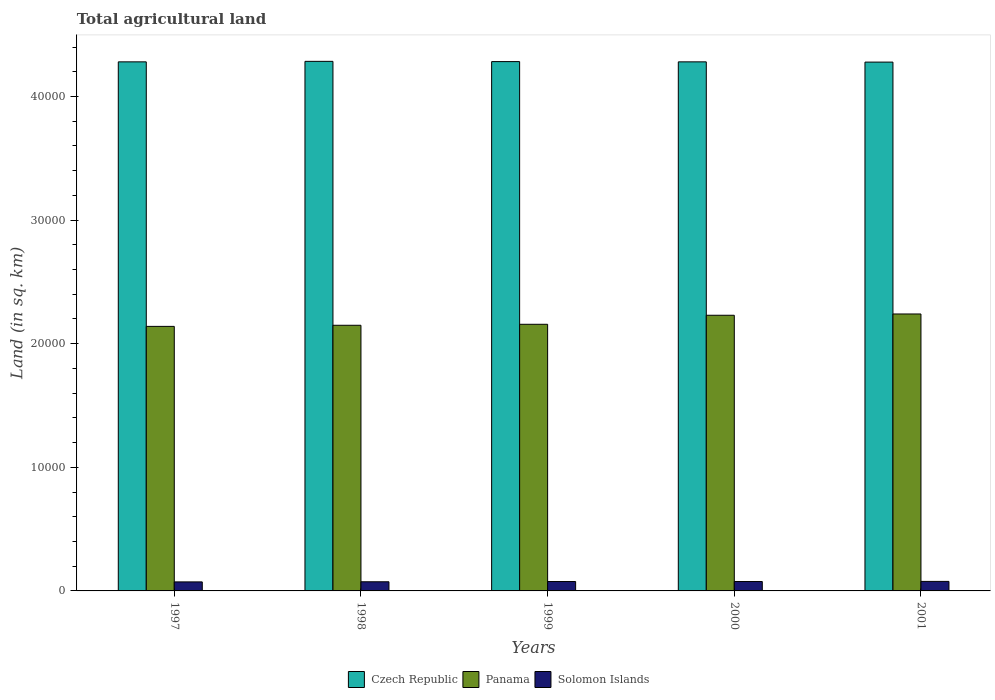How many groups of bars are there?
Offer a terse response. 5. Are the number of bars on each tick of the X-axis equal?
Make the answer very short. Yes. How many bars are there on the 1st tick from the right?
Your response must be concise. 3. What is the total agricultural land in Solomon Islands in 2001?
Offer a terse response. 770. Across all years, what is the maximum total agricultural land in Solomon Islands?
Provide a short and direct response. 770. Across all years, what is the minimum total agricultural land in Czech Republic?
Provide a short and direct response. 4.28e+04. In which year was the total agricultural land in Panama maximum?
Provide a short and direct response. 2001. What is the total total agricultural land in Panama in the graph?
Offer a terse response. 1.09e+05. What is the difference between the total agricultural land in Panama in 1997 and that in 1999?
Provide a succinct answer. -170. What is the difference between the total agricultural land in Solomon Islands in 2001 and the total agricultural land in Czech Republic in 1999?
Give a very brief answer. -4.20e+04. What is the average total agricultural land in Solomon Islands per year?
Make the answer very short. 752. In the year 1997, what is the difference between the total agricultural land in Panama and total agricultural land in Solomon Islands?
Ensure brevity in your answer.  2.07e+04. What is the ratio of the total agricultural land in Panama in 1998 to that in 2000?
Keep it short and to the point. 0.96. Is the total agricultural land in Czech Republic in 1998 less than that in 2000?
Ensure brevity in your answer.  No. Is the difference between the total agricultural land in Panama in 1997 and 1999 greater than the difference between the total agricultural land in Solomon Islands in 1997 and 1999?
Your answer should be compact. No. What is the difference between the highest and the second highest total agricultural land in Solomon Islands?
Your response must be concise. 10. What is the difference between the highest and the lowest total agricultural land in Solomon Islands?
Provide a succinct answer. 40. In how many years, is the total agricultural land in Panama greater than the average total agricultural land in Panama taken over all years?
Provide a short and direct response. 2. What does the 2nd bar from the left in 2001 represents?
Give a very brief answer. Panama. What does the 3rd bar from the right in 1998 represents?
Offer a very short reply. Czech Republic. Is it the case that in every year, the sum of the total agricultural land in Czech Republic and total agricultural land in Panama is greater than the total agricultural land in Solomon Islands?
Offer a terse response. Yes. How many bars are there?
Make the answer very short. 15. Are all the bars in the graph horizontal?
Your answer should be very brief. No. What is the difference between two consecutive major ticks on the Y-axis?
Offer a terse response. 10000. Does the graph contain any zero values?
Make the answer very short. No. How many legend labels are there?
Your response must be concise. 3. What is the title of the graph?
Your answer should be compact. Total agricultural land. What is the label or title of the Y-axis?
Offer a very short reply. Land (in sq. km). What is the Land (in sq. km) in Czech Republic in 1997?
Keep it short and to the point. 4.28e+04. What is the Land (in sq. km) in Panama in 1997?
Provide a short and direct response. 2.14e+04. What is the Land (in sq. km) in Solomon Islands in 1997?
Offer a very short reply. 730. What is the Land (in sq. km) of Czech Republic in 1998?
Your response must be concise. 4.28e+04. What is the Land (in sq. km) in Panama in 1998?
Your answer should be compact. 2.15e+04. What is the Land (in sq. km) of Solomon Islands in 1998?
Ensure brevity in your answer.  740. What is the Land (in sq. km) in Czech Republic in 1999?
Your answer should be compact. 4.28e+04. What is the Land (in sq. km) in Panama in 1999?
Your answer should be very brief. 2.16e+04. What is the Land (in sq. km) in Solomon Islands in 1999?
Provide a succinct answer. 760. What is the Land (in sq. km) in Czech Republic in 2000?
Your answer should be very brief. 4.28e+04. What is the Land (in sq. km) in Panama in 2000?
Offer a terse response. 2.23e+04. What is the Land (in sq. km) of Solomon Islands in 2000?
Make the answer very short. 760. What is the Land (in sq. km) in Czech Republic in 2001?
Ensure brevity in your answer.  4.28e+04. What is the Land (in sq. km) in Panama in 2001?
Keep it short and to the point. 2.24e+04. What is the Land (in sq. km) in Solomon Islands in 2001?
Offer a terse response. 770. Across all years, what is the maximum Land (in sq. km) in Czech Republic?
Provide a short and direct response. 4.28e+04. Across all years, what is the maximum Land (in sq. km) of Panama?
Make the answer very short. 2.24e+04. Across all years, what is the maximum Land (in sq. km) in Solomon Islands?
Your response must be concise. 770. Across all years, what is the minimum Land (in sq. km) of Czech Republic?
Your answer should be compact. 4.28e+04. Across all years, what is the minimum Land (in sq. km) of Panama?
Ensure brevity in your answer.  2.14e+04. Across all years, what is the minimum Land (in sq. km) in Solomon Islands?
Give a very brief answer. 730. What is the total Land (in sq. km) in Czech Republic in the graph?
Give a very brief answer. 2.14e+05. What is the total Land (in sq. km) of Panama in the graph?
Give a very brief answer. 1.09e+05. What is the total Land (in sq. km) in Solomon Islands in the graph?
Keep it short and to the point. 3760. What is the difference between the Land (in sq. km) of Panama in 1997 and that in 1998?
Keep it short and to the point. -90. What is the difference between the Land (in sq. km) of Czech Republic in 1997 and that in 1999?
Provide a short and direct response. -20. What is the difference between the Land (in sq. km) of Panama in 1997 and that in 1999?
Keep it short and to the point. -170. What is the difference between the Land (in sq. km) in Solomon Islands in 1997 and that in 1999?
Offer a terse response. -30. What is the difference between the Land (in sq. km) in Panama in 1997 and that in 2000?
Your response must be concise. -900. What is the difference between the Land (in sq. km) in Solomon Islands in 1997 and that in 2000?
Keep it short and to the point. -30. What is the difference between the Land (in sq. km) in Panama in 1997 and that in 2001?
Offer a very short reply. -1004. What is the difference between the Land (in sq. km) of Czech Republic in 1998 and that in 1999?
Make the answer very short. 20. What is the difference between the Land (in sq. km) in Panama in 1998 and that in 1999?
Offer a terse response. -80. What is the difference between the Land (in sq. km) of Solomon Islands in 1998 and that in 1999?
Make the answer very short. -20. What is the difference between the Land (in sq. km) in Panama in 1998 and that in 2000?
Your answer should be very brief. -810. What is the difference between the Land (in sq. km) in Panama in 1998 and that in 2001?
Give a very brief answer. -914. What is the difference between the Land (in sq. km) of Czech Republic in 1999 and that in 2000?
Your response must be concise. 20. What is the difference between the Land (in sq. km) in Panama in 1999 and that in 2000?
Your answer should be compact. -730. What is the difference between the Land (in sq. km) in Solomon Islands in 1999 and that in 2000?
Your answer should be compact. 0. What is the difference between the Land (in sq. km) in Czech Republic in 1999 and that in 2001?
Ensure brevity in your answer.  40. What is the difference between the Land (in sq. km) of Panama in 1999 and that in 2001?
Provide a succinct answer. -834. What is the difference between the Land (in sq. km) of Solomon Islands in 1999 and that in 2001?
Ensure brevity in your answer.  -10. What is the difference between the Land (in sq. km) in Czech Republic in 2000 and that in 2001?
Keep it short and to the point. 20. What is the difference between the Land (in sq. km) of Panama in 2000 and that in 2001?
Your response must be concise. -104. What is the difference between the Land (in sq. km) of Solomon Islands in 2000 and that in 2001?
Offer a very short reply. -10. What is the difference between the Land (in sq. km) of Czech Republic in 1997 and the Land (in sq. km) of Panama in 1998?
Provide a short and direct response. 2.13e+04. What is the difference between the Land (in sq. km) in Czech Republic in 1997 and the Land (in sq. km) in Solomon Islands in 1998?
Give a very brief answer. 4.21e+04. What is the difference between the Land (in sq. km) of Panama in 1997 and the Land (in sq. km) of Solomon Islands in 1998?
Your answer should be compact. 2.07e+04. What is the difference between the Land (in sq. km) of Czech Republic in 1997 and the Land (in sq. km) of Panama in 1999?
Your answer should be very brief. 2.12e+04. What is the difference between the Land (in sq. km) in Czech Republic in 1997 and the Land (in sq. km) in Solomon Islands in 1999?
Give a very brief answer. 4.20e+04. What is the difference between the Land (in sq. km) in Panama in 1997 and the Land (in sq. km) in Solomon Islands in 1999?
Provide a succinct answer. 2.06e+04. What is the difference between the Land (in sq. km) in Czech Republic in 1997 and the Land (in sq. km) in Panama in 2000?
Your answer should be very brief. 2.05e+04. What is the difference between the Land (in sq. km) in Czech Republic in 1997 and the Land (in sq. km) in Solomon Islands in 2000?
Offer a very short reply. 4.20e+04. What is the difference between the Land (in sq. km) in Panama in 1997 and the Land (in sq. km) in Solomon Islands in 2000?
Give a very brief answer. 2.06e+04. What is the difference between the Land (in sq. km) in Czech Republic in 1997 and the Land (in sq. km) in Panama in 2001?
Offer a very short reply. 2.04e+04. What is the difference between the Land (in sq. km) of Czech Republic in 1997 and the Land (in sq. km) of Solomon Islands in 2001?
Your response must be concise. 4.20e+04. What is the difference between the Land (in sq. km) in Panama in 1997 and the Land (in sq. km) in Solomon Islands in 2001?
Provide a short and direct response. 2.06e+04. What is the difference between the Land (in sq. km) in Czech Republic in 1998 and the Land (in sq. km) in Panama in 1999?
Your response must be concise. 2.13e+04. What is the difference between the Land (in sq. km) in Czech Republic in 1998 and the Land (in sq. km) in Solomon Islands in 1999?
Give a very brief answer. 4.21e+04. What is the difference between the Land (in sq. km) of Panama in 1998 and the Land (in sq. km) of Solomon Islands in 1999?
Keep it short and to the point. 2.07e+04. What is the difference between the Land (in sq. km) in Czech Republic in 1998 and the Land (in sq. km) in Panama in 2000?
Your answer should be compact. 2.05e+04. What is the difference between the Land (in sq. km) in Czech Republic in 1998 and the Land (in sq. km) in Solomon Islands in 2000?
Offer a terse response. 4.21e+04. What is the difference between the Land (in sq. km) in Panama in 1998 and the Land (in sq. km) in Solomon Islands in 2000?
Provide a short and direct response. 2.07e+04. What is the difference between the Land (in sq. km) in Czech Republic in 1998 and the Land (in sq. km) in Panama in 2001?
Offer a terse response. 2.04e+04. What is the difference between the Land (in sq. km) of Czech Republic in 1998 and the Land (in sq. km) of Solomon Islands in 2001?
Keep it short and to the point. 4.21e+04. What is the difference between the Land (in sq. km) of Panama in 1998 and the Land (in sq. km) of Solomon Islands in 2001?
Offer a terse response. 2.07e+04. What is the difference between the Land (in sq. km) of Czech Republic in 1999 and the Land (in sq. km) of Panama in 2000?
Offer a terse response. 2.05e+04. What is the difference between the Land (in sq. km) in Czech Republic in 1999 and the Land (in sq. km) in Solomon Islands in 2000?
Make the answer very short. 4.21e+04. What is the difference between the Land (in sq. km) of Panama in 1999 and the Land (in sq. km) of Solomon Islands in 2000?
Ensure brevity in your answer.  2.08e+04. What is the difference between the Land (in sq. km) of Czech Republic in 1999 and the Land (in sq. km) of Panama in 2001?
Ensure brevity in your answer.  2.04e+04. What is the difference between the Land (in sq. km) of Czech Republic in 1999 and the Land (in sq. km) of Solomon Islands in 2001?
Offer a terse response. 4.20e+04. What is the difference between the Land (in sq. km) of Panama in 1999 and the Land (in sq. km) of Solomon Islands in 2001?
Make the answer very short. 2.08e+04. What is the difference between the Land (in sq. km) of Czech Republic in 2000 and the Land (in sq. km) of Panama in 2001?
Give a very brief answer. 2.04e+04. What is the difference between the Land (in sq. km) of Czech Republic in 2000 and the Land (in sq. km) of Solomon Islands in 2001?
Make the answer very short. 4.20e+04. What is the difference between the Land (in sq. km) of Panama in 2000 and the Land (in sq. km) of Solomon Islands in 2001?
Keep it short and to the point. 2.15e+04. What is the average Land (in sq. km) in Czech Republic per year?
Your answer should be very brief. 4.28e+04. What is the average Land (in sq. km) of Panama per year?
Offer a very short reply. 2.18e+04. What is the average Land (in sq. km) of Solomon Islands per year?
Keep it short and to the point. 752. In the year 1997, what is the difference between the Land (in sq. km) in Czech Republic and Land (in sq. km) in Panama?
Make the answer very short. 2.14e+04. In the year 1997, what is the difference between the Land (in sq. km) in Czech Republic and Land (in sq. km) in Solomon Islands?
Give a very brief answer. 4.21e+04. In the year 1997, what is the difference between the Land (in sq. km) in Panama and Land (in sq. km) in Solomon Islands?
Your response must be concise. 2.07e+04. In the year 1998, what is the difference between the Land (in sq. km) of Czech Republic and Land (in sq. km) of Panama?
Provide a short and direct response. 2.14e+04. In the year 1998, what is the difference between the Land (in sq. km) in Czech Republic and Land (in sq. km) in Solomon Islands?
Ensure brevity in your answer.  4.21e+04. In the year 1998, what is the difference between the Land (in sq. km) in Panama and Land (in sq. km) in Solomon Islands?
Your answer should be compact. 2.08e+04. In the year 1999, what is the difference between the Land (in sq. km) in Czech Republic and Land (in sq. km) in Panama?
Keep it short and to the point. 2.12e+04. In the year 1999, what is the difference between the Land (in sq. km) in Czech Republic and Land (in sq. km) in Solomon Islands?
Your response must be concise. 4.21e+04. In the year 1999, what is the difference between the Land (in sq. km) of Panama and Land (in sq. km) of Solomon Islands?
Your answer should be very brief. 2.08e+04. In the year 2000, what is the difference between the Land (in sq. km) of Czech Republic and Land (in sq. km) of Panama?
Your response must be concise. 2.05e+04. In the year 2000, what is the difference between the Land (in sq. km) of Czech Republic and Land (in sq. km) of Solomon Islands?
Give a very brief answer. 4.20e+04. In the year 2000, what is the difference between the Land (in sq. km) of Panama and Land (in sq. km) of Solomon Islands?
Provide a short and direct response. 2.15e+04. In the year 2001, what is the difference between the Land (in sq. km) of Czech Republic and Land (in sq. km) of Panama?
Offer a very short reply. 2.04e+04. In the year 2001, what is the difference between the Land (in sq. km) in Czech Republic and Land (in sq. km) in Solomon Islands?
Ensure brevity in your answer.  4.20e+04. In the year 2001, what is the difference between the Land (in sq. km) of Panama and Land (in sq. km) of Solomon Islands?
Your response must be concise. 2.16e+04. What is the ratio of the Land (in sq. km) in Solomon Islands in 1997 to that in 1998?
Provide a short and direct response. 0.99. What is the ratio of the Land (in sq. km) in Czech Republic in 1997 to that in 1999?
Your answer should be very brief. 1. What is the ratio of the Land (in sq. km) of Solomon Islands in 1997 to that in 1999?
Offer a very short reply. 0.96. What is the ratio of the Land (in sq. km) in Czech Republic in 1997 to that in 2000?
Make the answer very short. 1. What is the ratio of the Land (in sq. km) in Panama in 1997 to that in 2000?
Make the answer very short. 0.96. What is the ratio of the Land (in sq. km) of Solomon Islands in 1997 to that in 2000?
Give a very brief answer. 0.96. What is the ratio of the Land (in sq. km) in Czech Republic in 1997 to that in 2001?
Offer a terse response. 1. What is the ratio of the Land (in sq. km) of Panama in 1997 to that in 2001?
Give a very brief answer. 0.96. What is the ratio of the Land (in sq. km) of Solomon Islands in 1997 to that in 2001?
Offer a terse response. 0.95. What is the ratio of the Land (in sq. km) in Czech Republic in 1998 to that in 1999?
Your answer should be compact. 1. What is the ratio of the Land (in sq. km) in Solomon Islands in 1998 to that in 1999?
Offer a terse response. 0.97. What is the ratio of the Land (in sq. km) in Panama in 1998 to that in 2000?
Offer a terse response. 0.96. What is the ratio of the Land (in sq. km) of Solomon Islands in 1998 to that in 2000?
Offer a terse response. 0.97. What is the ratio of the Land (in sq. km) of Panama in 1998 to that in 2001?
Your response must be concise. 0.96. What is the ratio of the Land (in sq. km) in Solomon Islands in 1998 to that in 2001?
Provide a short and direct response. 0.96. What is the ratio of the Land (in sq. km) of Panama in 1999 to that in 2000?
Ensure brevity in your answer.  0.97. What is the ratio of the Land (in sq. km) of Solomon Islands in 1999 to that in 2000?
Offer a terse response. 1. What is the ratio of the Land (in sq. km) in Panama in 1999 to that in 2001?
Offer a terse response. 0.96. What is the ratio of the Land (in sq. km) in Panama in 2000 to that in 2001?
Give a very brief answer. 1. What is the ratio of the Land (in sq. km) of Solomon Islands in 2000 to that in 2001?
Offer a very short reply. 0.99. What is the difference between the highest and the second highest Land (in sq. km) of Czech Republic?
Your answer should be compact. 20. What is the difference between the highest and the second highest Land (in sq. km) in Panama?
Your answer should be compact. 104. What is the difference between the highest and the lowest Land (in sq. km) of Czech Republic?
Provide a short and direct response. 60. What is the difference between the highest and the lowest Land (in sq. km) of Panama?
Offer a terse response. 1004. 